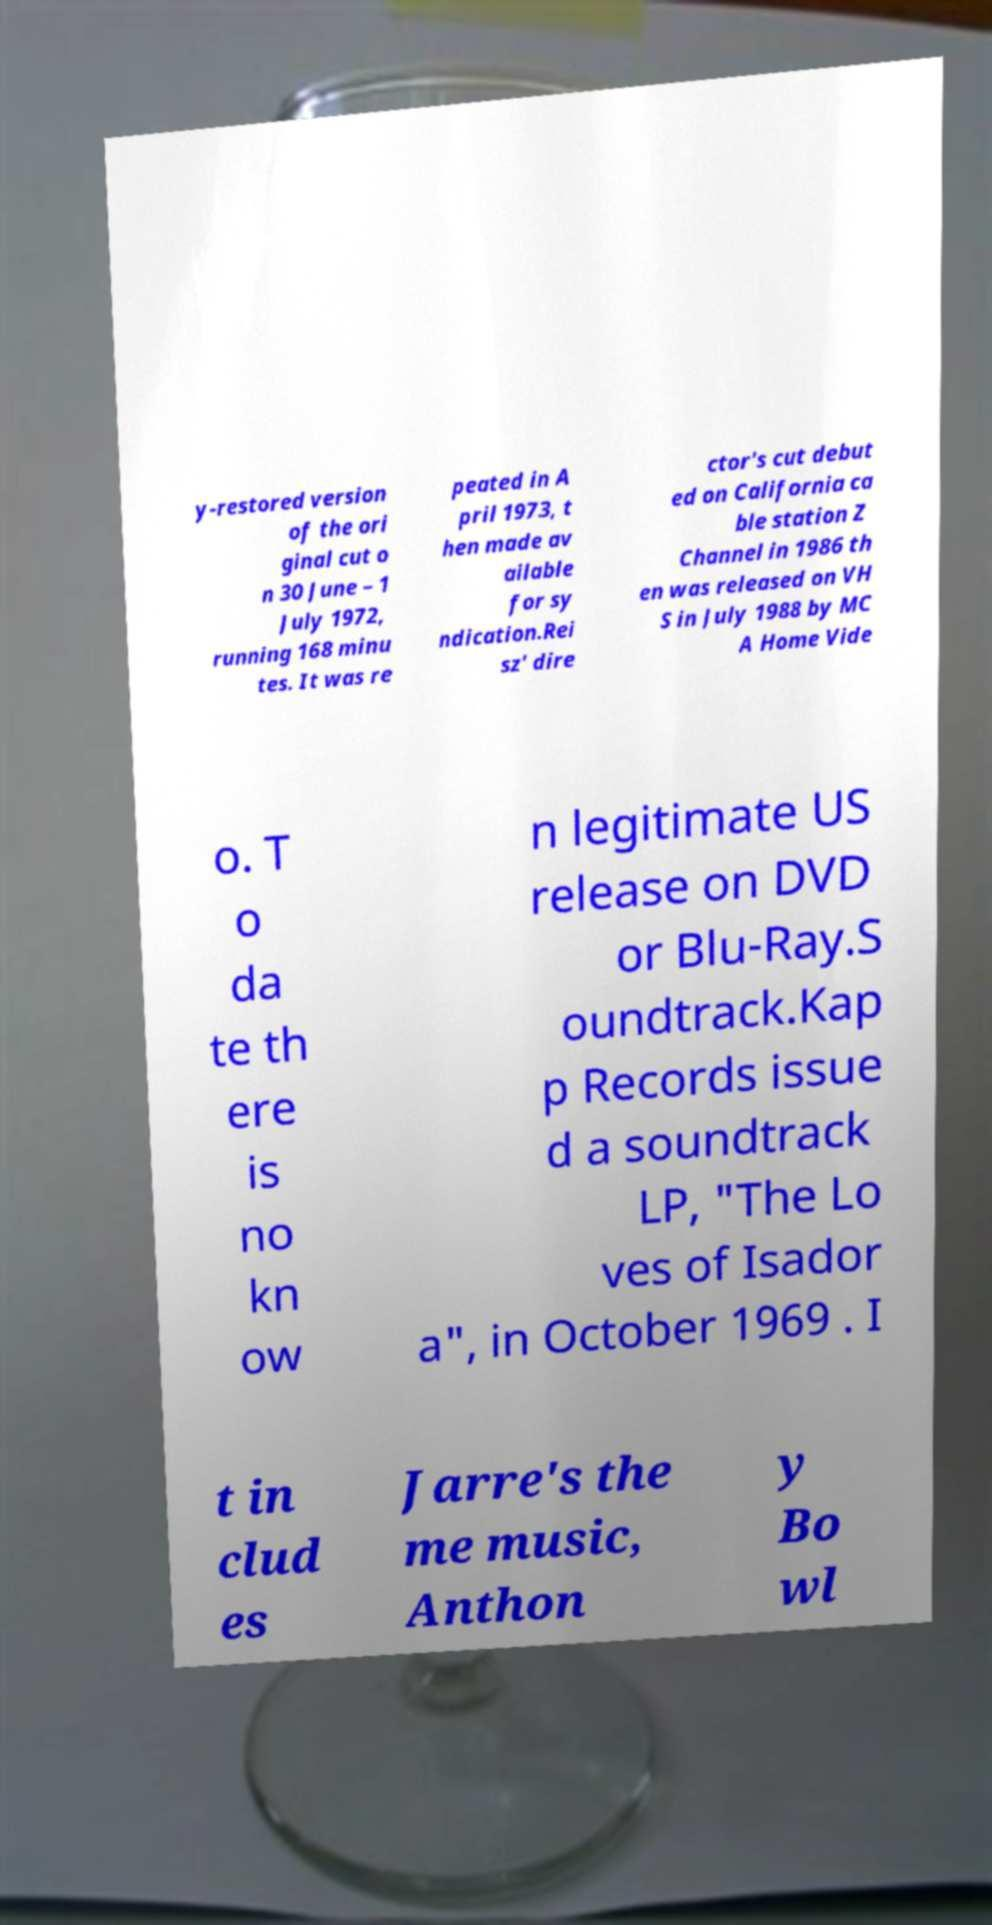For documentation purposes, I need the text within this image transcribed. Could you provide that? y-restored version of the ori ginal cut o n 30 June – 1 July 1972, running 168 minu tes. It was re peated in A pril 1973, t hen made av ailable for sy ndication.Rei sz' dire ctor's cut debut ed on California ca ble station Z Channel in 1986 th en was released on VH S in July 1988 by MC A Home Vide o. T o da te th ere is no kn ow n legitimate US release on DVD or Blu-Ray.S oundtrack.Kap p Records issue d a soundtrack LP, "The Lo ves of Isador a", in October 1969 . I t in clud es Jarre's the me music, Anthon y Bo wl 